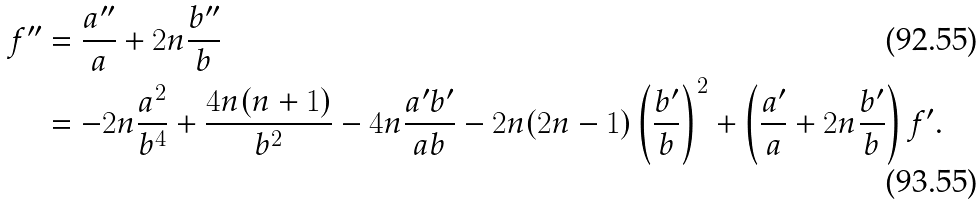<formula> <loc_0><loc_0><loc_500><loc_500>f ^ { \prime \prime } & = \frac { a ^ { \prime \prime } } { a } + 2 n \frac { b ^ { \prime \prime } } { b } \\ & = - 2 n \frac { a ^ { 2 } } { b ^ { 4 } } + \frac { 4 n ( n + 1 ) } { b ^ { 2 } } - 4 n \frac { a ^ { \prime } b ^ { \prime } } { a b } - 2 n ( 2 n - 1 ) \left ( \frac { b ^ { \prime } } { b } \right ) ^ { 2 } + \left ( \frac { a ^ { \prime } } { a } + 2 n \frac { b ^ { \prime } } { b } \right ) f ^ { \prime } .</formula> 